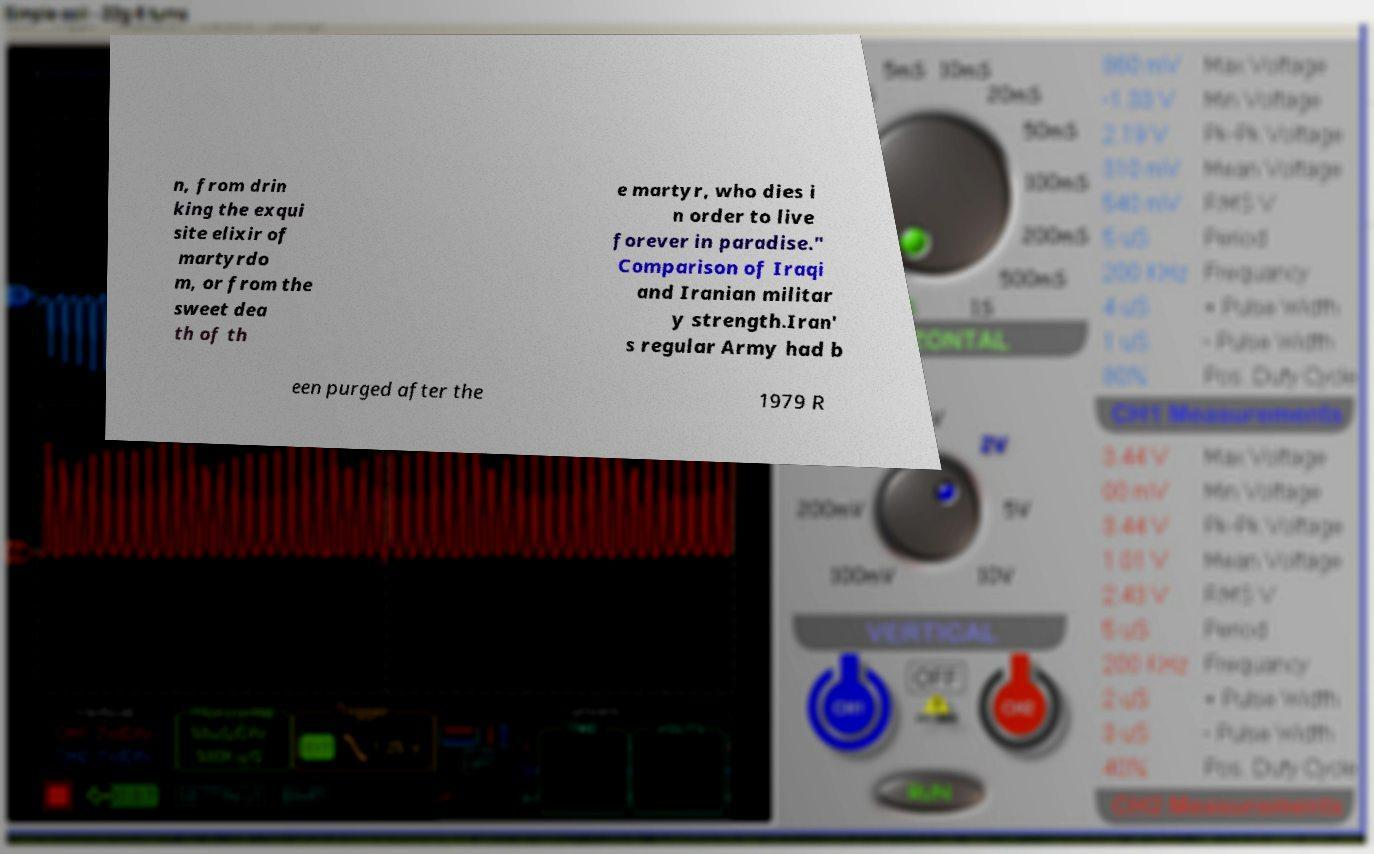I need the written content from this picture converted into text. Can you do that? n, from drin king the exqui site elixir of martyrdo m, or from the sweet dea th of th e martyr, who dies i n order to live forever in paradise." Comparison of Iraqi and Iranian militar y strength.Iran' s regular Army had b een purged after the 1979 R 